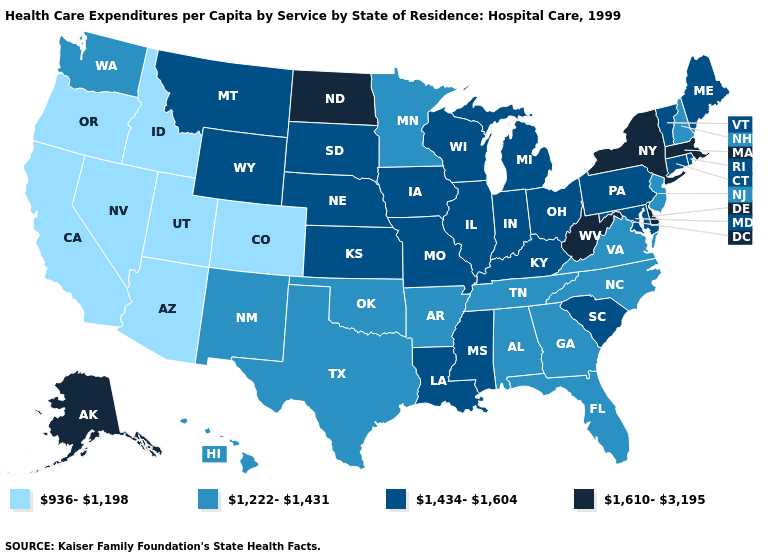Which states have the lowest value in the USA?
Write a very short answer. Arizona, California, Colorado, Idaho, Nevada, Oregon, Utah. Which states have the lowest value in the USA?
Answer briefly. Arizona, California, Colorado, Idaho, Nevada, Oregon, Utah. What is the value of North Dakota?
Answer briefly. 1,610-3,195. Does Colorado have the lowest value in the USA?
Give a very brief answer. Yes. What is the highest value in the West ?
Short answer required. 1,610-3,195. Does South Dakota have the lowest value in the USA?
Short answer required. No. What is the highest value in the Northeast ?
Write a very short answer. 1,610-3,195. Which states have the highest value in the USA?
Give a very brief answer. Alaska, Delaware, Massachusetts, New York, North Dakota, West Virginia. Name the states that have a value in the range 1,434-1,604?
Keep it brief. Connecticut, Illinois, Indiana, Iowa, Kansas, Kentucky, Louisiana, Maine, Maryland, Michigan, Mississippi, Missouri, Montana, Nebraska, Ohio, Pennsylvania, Rhode Island, South Carolina, South Dakota, Vermont, Wisconsin, Wyoming. What is the highest value in states that border Utah?
Quick response, please. 1,434-1,604. What is the value of Hawaii?
Short answer required. 1,222-1,431. Which states have the highest value in the USA?
Quick response, please. Alaska, Delaware, Massachusetts, New York, North Dakota, West Virginia. Name the states that have a value in the range 1,222-1,431?
Write a very short answer. Alabama, Arkansas, Florida, Georgia, Hawaii, Minnesota, New Hampshire, New Jersey, New Mexico, North Carolina, Oklahoma, Tennessee, Texas, Virginia, Washington. Does the first symbol in the legend represent the smallest category?
Quick response, please. Yes. Name the states that have a value in the range 1,434-1,604?
Give a very brief answer. Connecticut, Illinois, Indiana, Iowa, Kansas, Kentucky, Louisiana, Maine, Maryland, Michigan, Mississippi, Missouri, Montana, Nebraska, Ohio, Pennsylvania, Rhode Island, South Carolina, South Dakota, Vermont, Wisconsin, Wyoming. 